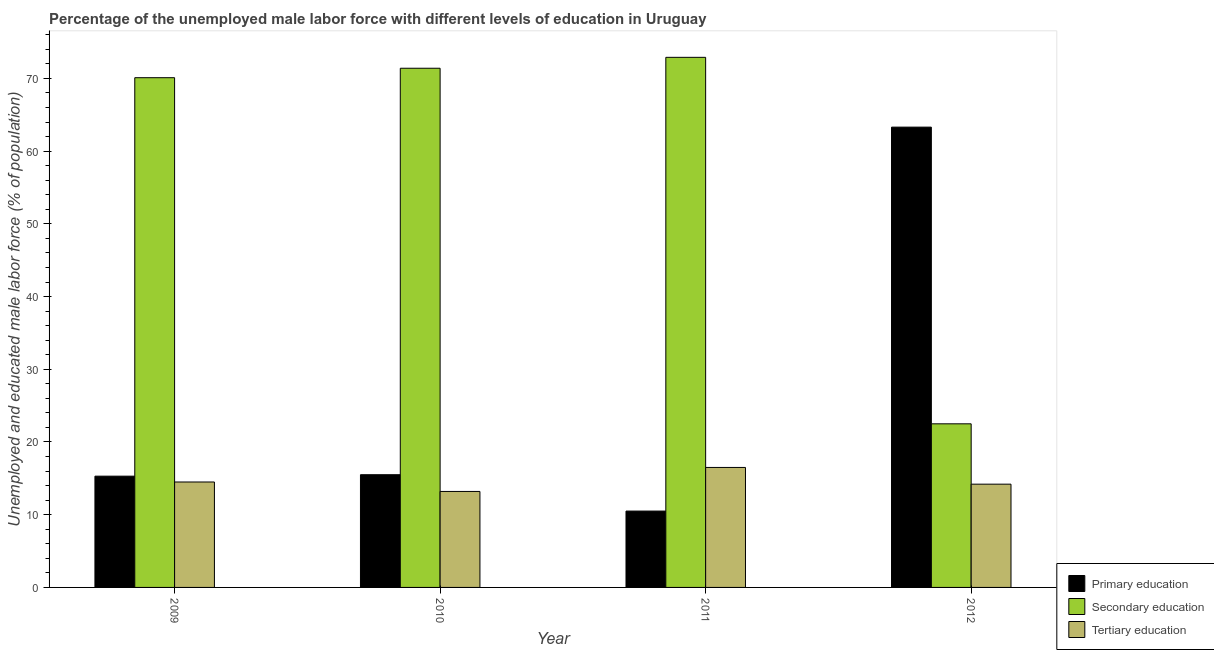Are the number of bars on each tick of the X-axis equal?
Offer a terse response. Yes. How many bars are there on the 4th tick from the left?
Provide a succinct answer. 3. What is the label of the 1st group of bars from the left?
Ensure brevity in your answer.  2009. In how many cases, is the number of bars for a given year not equal to the number of legend labels?
Offer a terse response. 0. What is the percentage of male labor force who received tertiary education in 2010?
Keep it short and to the point. 13.2. In which year was the percentage of male labor force who received tertiary education maximum?
Ensure brevity in your answer.  2011. What is the total percentage of male labor force who received primary education in the graph?
Offer a terse response. 104.6. What is the difference between the percentage of male labor force who received primary education in 2010 and that in 2012?
Your answer should be very brief. -47.8. What is the difference between the percentage of male labor force who received secondary education in 2010 and the percentage of male labor force who received primary education in 2012?
Ensure brevity in your answer.  48.9. What is the average percentage of male labor force who received primary education per year?
Provide a succinct answer. 26.15. In the year 2009, what is the difference between the percentage of male labor force who received secondary education and percentage of male labor force who received primary education?
Ensure brevity in your answer.  0. What is the ratio of the percentage of male labor force who received primary education in 2010 to that in 2011?
Offer a terse response. 1.48. Is the percentage of male labor force who received tertiary education in 2009 less than that in 2010?
Keep it short and to the point. No. Is the difference between the percentage of male labor force who received secondary education in 2009 and 2012 greater than the difference between the percentage of male labor force who received tertiary education in 2009 and 2012?
Ensure brevity in your answer.  No. What is the difference between the highest and the lowest percentage of male labor force who received primary education?
Give a very brief answer. 52.8. In how many years, is the percentage of male labor force who received tertiary education greater than the average percentage of male labor force who received tertiary education taken over all years?
Keep it short and to the point. 1. What does the 2nd bar from the right in 2009 represents?
Your answer should be compact. Secondary education. How many bars are there?
Offer a very short reply. 12. How many years are there in the graph?
Your answer should be compact. 4. What is the difference between two consecutive major ticks on the Y-axis?
Provide a short and direct response. 10. Does the graph contain any zero values?
Provide a short and direct response. No. Does the graph contain grids?
Give a very brief answer. No. How are the legend labels stacked?
Keep it short and to the point. Vertical. What is the title of the graph?
Make the answer very short. Percentage of the unemployed male labor force with different levels of education in Uruguay. Does "Male employers" appear as one of the legend labels in the graph?
Offer a very short reply. No. What is the label or title of the X-axis?
Provide a succinct answer. Year. What is the label or title of the Y-axis?
Your answer should be compact. Unemployed and educated male labor force (% of population). What is the Unemployed and educated male labor force (% of population) of Primary education in 2009?
Keep it short and to the point. 15.3. What is the Unemployed and educated male labor force (% of population) in Secondary education in 2009?
Ensure brevity in your answer.  70.1. What is the Unemployed and educated male labor force (% of population) of Tertiary education in 2009?
Your answer should be very brief. 14.5. What is the Unemployed and educated male labor force (% of population) of Primary education in 2010?
Keep it short and to the point. 15.5. What is the Unemployed and educated male labor force (% of population) in Secondary education in 2010?
Your answer should be very brief. 71.4. What is the Unemployed and educated male labor force (% of population) of Tertiary education in 2010?
Keep it short and to the point. 13.2. What is the Unemployed and educated male labor force (% of population) of Primary education in 2011?
Your response must be concise. 10.5. What is the Unemployed and educated male labor force (% of population) in Secondary education in 2011?
Make the answer very short. 72.9. What is the Unemployed and educated male labor force (% of population) in Primary education in 2012?
Your answer should be compact. 63.3. What is the Unemployed and educated male labor force (% of population) in Secondary education in 2012?
Provide a succinct answer. 22.5. What is the Unemployed and educated male labor force (% of population) in Tertiary education in 2012?
Provide a succinct answer. 14.2. Across all years, what is the maximum Unemployed and educated male labor force (% of population) of Primary education?
Your response must be concise. 63.3. Across all years, what is the maximum Unemployed and educated male labor force (% of population) in Secondary education?
Give a very brief answer. 72.9. Across all years, what is the minimum Unemployed and educated male labor force (% of population) in Primary education?
Your response must be concise. 10.5. Across all years, what is the minimum Unemployed and educated male labor force (% of population) of Secondary education?
Ensure brevity in your answer.  22.5. Across all years, what is the minimum Unemployed and educated male labor force (% of population) in Tertiary education?
Offer a terse response. 13.2. What is the total Unemployed and educated male labor force (% of population) in Primary education in the graph?
Offer a terse response. 104.6. What is the total Unemployed and educated male labor force (% of population) in Secondary education in the graph?
Provide a succinct answer. 236.9. What is the total Unemployed and educated male labor force (% of population) in Tertiary education in the graph?
Keep it short and to the point. 58.4. What is the difference between the Unemployed and educated male labor force (% of population) in Primary education in 2009 and that in 2010?
Offer a terse response. -0.2. What is the difference between the Unemployed and educated male labor force (% of population) in Secondary education in 2009 and that in 2010?
Ensure brevity in your answer.  -1.3. What is the difference between the Unemployed and educated male labor force (% of population) in Primary education in 2009 and that in 2012?
Offer a terse response. -48. What is the difference between the Unemployed and educated male labor force (% of population) of Secondary education in 2009 and that in 2012?
Your answer should be very brief. 47.6. What is the difference between the Unemployed and educated male labor force (% of population) in Tertiary education in 2010 and that in 2011?
Your answer should be very brief. -3.3. What is the difference between the Unemployed and educated male labor force (% of population) in Primary education in 2010 and that in 2012?
Offer a terse response. -47.8. What is the difference between the Unemployed and educated male labor force (% of population) in Secondary education in 2010 and that in 2012?
Your answer should be compact. 48.9. What is the difference between the Unemployed and educated male labor force (% of population) in Tertiary education in 2010 and that in 2012?
Your answer should be very brief. -1. What is the difference between the Unemployed and educated male labor force (% of population) in Primary education in 2011 and that in 2012?
Provide a succinct answer. -52.8. What is the difference between the Unemployed and educated male labor force (% of population) of Secondary education in 2011 and that in 2012?
Provide a short and direct response. 50.4. What is the difference between the Unemployed and educated male labor force (% of population) of Primary education in 2009 and the Unemployed and educated male labor force (% of population) of Secondary education in 2010?
Offer a very short reply. -56.1. What is the difference between the Unemployed and educated male labor force (% of population) in Secondary education in 2009 and the Unemployed and educated male labor force (% of population) in Tertiary education in 2010?
Provide a succinct answer. 56.9. What is the difference between the Unemployed and educated male labor force (% of population) of Primary education in 2009 and the Unemployed and educated male labor force (% of population) of Secondary education in 2011?
Offer a very short reply. -57.6. What is the difference between the Unemployed and educated male labor force (% of population) of Primary education in 2009 and the Unemployed and educated male labor force (% of population) of Tertiary education in 2011?
Your answer should be very brief. -1.2. What is the difference between the Unemployed and educated male labor force (% of population) in Secondary education in 2009 and the Unemployed and educated male labor force (% of population) in Tertiary education in 2011?
Provide a short and direct response. 53.6. What is the difference between the Unemployed and educated male labor force (% of population) of Secondary education in 2009 and the Unemployed and educated male labor force (% of population) of Tertiary education in 2012?
Give a very brief answer. 55.9. What is the difference between the Unemployed and educated male labor force (% of population) in Primary education in 2010 and the Unemployed and educated male labor force (% of population) in Secondary education in 2011?
Provide a succinct answer. -57.4. What is the difference between the Unemployed and educated male labor force (% of population) in Primary education in 2010 and the Unemployed and educated male labor force (% of population) in Tertiary education in 2011?
Give a very brief answer. -1. What is the difference between the Unemployed and educated male labor force (% of population) of Secondary education in 2010 and the Unemployed and educated male labor force (% of population) of Tertiary education in 2011?
Keep it short and to the point. 54.9. What is the difference between the Unemployed and educated male labor force (% of population) of Primary education in 2010 and the Unemployed and educated male labor force (% of population) of Secondary education in 2012?
Your answer should be very brief. -7. What is the difference between the Unemployed and educated male labor force (% of population) of Secondary education in 2010 and the Unemployed and educated male labor force (% of population) of Tertiary education in 2012?
Your response must be concise. 57.2. What is the difference between the Unemployed and educated male labor force (% of population) of Secondary education in 2011 and the Unemployed and educated male labor force (% of population) of Tertiary education in 2012?
Your answer should be very brief. 58.7. What is the average Unemployed and educated male labor force (% of population) in Primary education per year?
Your answer should be very brief. 26.15. What is the average Unemployed and educated male labor force (% of population) in Secondary education per year?
Your answer should be very brief. 59.23. What is the average Unemployed and educated male labor force (% of population) of Tertiary education per year?
Keep it short and to the point. 14.6. In the year 2009, what is the difference between the Unemployed and educated male labor force (% of population) in Primary education and Unemployed and educated male labor force (% of population) in Secondary education?
Offer a very short reply. -54.8. In the year 2009, what is the difference between the Unemployed and educated male labor force (% of population) of Primary education and Unemployed and educated male labor force (% of population) of Tertiary education?
Provide a succinct answer. 0.8. In the year 2009, what is the difference between the Unemployed and educated male labor force (% of population) in Secondary education and Unemployed and educated male labor force (% of population) in Tertiary education?
Offer a very short reply. 55.6. In the year 2010, what is the difference between the Unemployed and educated male labor force (% of population) of Primary education and Unemployed and educated male labor force (% of population) of Secondary education?
Give a very brief answer. -55.9. In the year 2010, what is the difference between the Unemployed and educated male labor force (% of population) of Secondary education and Unemployed and educated male labor force (% of population) of Tertiary education?
Offer a very short reply. 58.2. In the year 2011, what is the difference between the Unemployed and educated male labor force (% of population) of Primary education and Unemployed and educated male labor force (% of population) of Secondary education?
Your response must be concise. -62.4. In the year 2011, what is the difference between the Unemployed and educated male labor force (% of population) in Primary education and Unemployed and educated male labor force (% of population) in Tertiary education?
Your answer should be compact. -6. In the year 2011, what is the difference between the Unemployed and educated male labor force (% of population) in Secondary education and Unemployed and educated male labor force (% of population) in Tertiary education?
Provide a short and direct response. 56.4. In the year 2012, what is the difference between the Unemployed and educated male labor force (% of population) of Primary education and Unemployed and educated male labor force (% of population) of Secondary education?
Make the answer very short. 40.8. In the year 2012, what is the difference between the Unemployed and educated male labor force (% of population) of Primary education and Unemployed and educated male labor force (% of population) of Tertiary education?
Give a very brief answer. 49.1. What is the ratio of the Unemployed and educated male labor force (% of population) in Primary education in 2009 to that in 2010?
Provide a succinct answer. 0.99. What is the ratio of the Unemployed and educated male labor force (% of population) of Secondary education in 2009 to that in 2010?
Provide a succinct answer. 0.98. What is the ratio of the Unemployed and educated male labor force (% of population) of Tertiary education in 2009 to that in 2010?
Your answer should be compact. 1.1. What is the ratio of the Unemployed and educated male labor force (% of population) in Primary education in 2009 to that in 2011?
Provide a succinct answer. 1.46. What is the ratio of the Unemployed and educated male labor force (% of population) of Secondary education in 2009 to that in 2011?
Ensure brevity in your answer.  0.96. What is the ratio of the Unemployed and educated male labor force (% of population) in Tertiary education in 2009 to that in 2011?
Make the answer very short. 0.88. What is the ratio of the Unemployed and educated male labor force (% of population) in Primary education in 2009 to that in 2012?
Give a very brief answer. 0.24. What is the ratio of the Unemployed and educated male labor force (% of population) of Secondary education in 2009 to that in 2012?
Give a very brief answer. 3.12. What is the ratio of the Unemployed and educated male labor force (% of population) of Tertiary education in 2009 to that in 2012?
Your answer should be very brief. 1.02. What is the ratio of the Unemployed and educated male labor force (% of population) of Primary education in 2010 to that in 2011?
Provide a succinct answer. 1.48. What is the ratio of the Unemployed and educated male labor force (% of population) in Secondary education in 2010 to that in 2011?
Make the answer very short. 0.98. What is the ratio of the Unemployed and educated male labor force (% of population) in Primary education in 2010 to that in 2012?
Offer a very short reply. 0.24. What is the ratio of the Unemployed and educated male labor force (% of population) of Secondary education in 2010 to that in 2012?
Offer a terse response. 3.17. What is the ratio of the Unemployed and educated male labor force (% of population) of Tertiary education in 2010 to that in 2012?
Keep it short and to the point. 0.93. What is the ratio of the Unemployed and educated male labor force (% of population) in Primary education in 2011 to that in 2012?
Offer a very short reply. 0.17. What is the ratio of the Unemployed and educated male labor force (% of population) in Secondary education in 2011 to that in 2012?
Your answer should be very brief. 3.24. What is the ratio of the Unemployed and educated male labor force (% of population) in Tertiary education in 2011 to that in 2012?
Provide a short and direct response. 1.16. What is the difference between the highest and the second highest Unemployed and educated male labor force (% of population) in Primary education?
Provide a succinct answer. 47.8. What is the difference between the highest and the lowest Unemployed and educated male labor force (% of population) of Primary education?
Provide a short and direct response. 52.8. What is the difference between the highest and the lowest Unemployed and educated male labor force (% of population) of Secondary education?
Provide a succinct answer. 50.4. What is the difference between the highest and the lowest Unemployed and educated male labor force (% of population) of Tertiary education?
Your response must be concise. 3.3. 